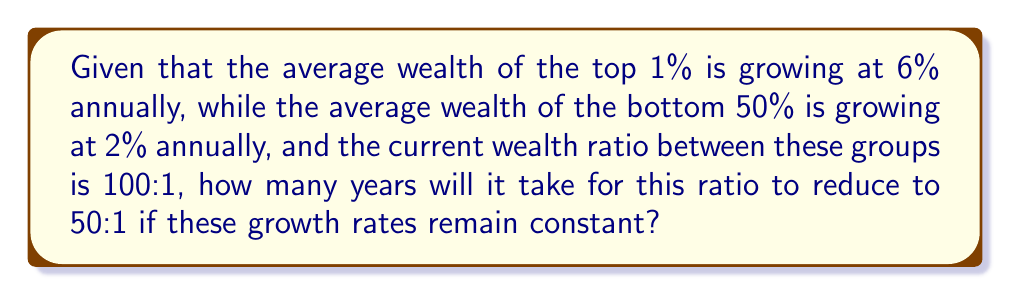What is the answer to this math problem? Let's approach this step-by-step:

1) Let $W_t$ be the wealth of the top 1% and $W_b$ be the wealth of the bottom 50% at the start.
   The initial ratio is 100:1, so:
   
   $$\frac{W_t}{W_b} = 100$$

2) After $n$ years, the wealth of each group will be:
   
   Top 1%: $W_t(1.06)^n$
   Bottom 50%: $W_b(1.02)^n$

3) We want to find $n$ when the ratio becomes 50:1:

   $$\frac{W_t(1.06)^n}{W_b(1.02)^n} = 50$$

4) Substituting $W_t = 100W_b$ from step 1:

   $$\frac{100W_b(1.06)^n}{W_b(1.02)^n} = 50$$

5) The $W_b$ cancels out:

   $$100 \cdot \frac{(1.06)^n}{(1.02)^n} = 50$$

6) Simplify:

   $$2 \cdot (\frac{1.06}{1.02})^n = 1$$

7) Take the natural log of both sides:

   $$n \cdot \ln(\frac{1.06}{1.02}) = \ln(\frac{1}{2})$$

8) Solve for $n$:

   $$n = \frac{\ln(0.5)}{\ln(1.06/1.02)} \approx 35.7$$
Answer: Approximately 36 years 